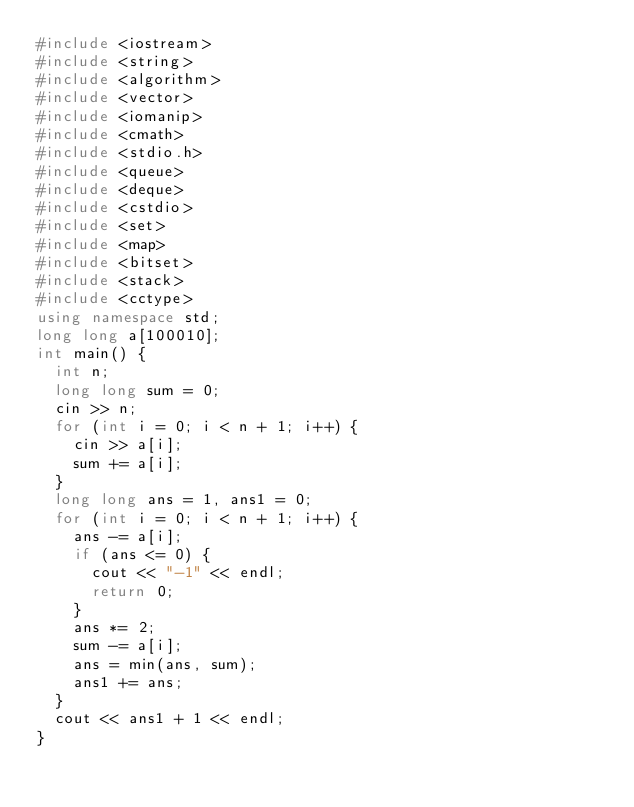Convert code to text. <code><loc_0><loc_0><loc_500><loc_500><_C++_>#include <iostream>
#include <string>
#include <algorithm>
#include <vector>
#include <iomanip>
#include <cmath>
#include <stdio.h>
#include <queue>
#include <deque>
#include <cstdio>
#include <set>
#include <map>
#include <bitset>
#include <stack>
#include <cctype>
using namespace std;
long long a[100010];
int main() {
	int n;
	long long sum = 0;
	cin >> n;
	for (int i = 0; i < n + 1; i++) {
		cin >> a[i];
		sum += a[i];
	}
	long long ans = 1, ans1 = 0;
	for (int i = 0; i < n + 1; i++) {
		ans -= a[i];
		if (ans <= 0) {
			cout << "-1" << endl;
			return 0;
		}
		ans *= 2;
		sum -= a[i];
		ans = min(ans, sum);
		ans1 += ans;
	}
	cout << ans1 + 1 << endl;
}
</code> 